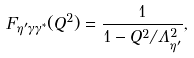Convert formula to latex. <formula><loc_0><loc_0><loc_500><loc_500>F _ { \eta ^ { \prime } \gamma \gamma ^ { * } } ( Q ^ { 2 } ) = \frac { 1 } { 1 - Q ^ { 2 } / \Lambda _ { \eta ^ { \prime } } ^ { 2 } } ,</formula> 